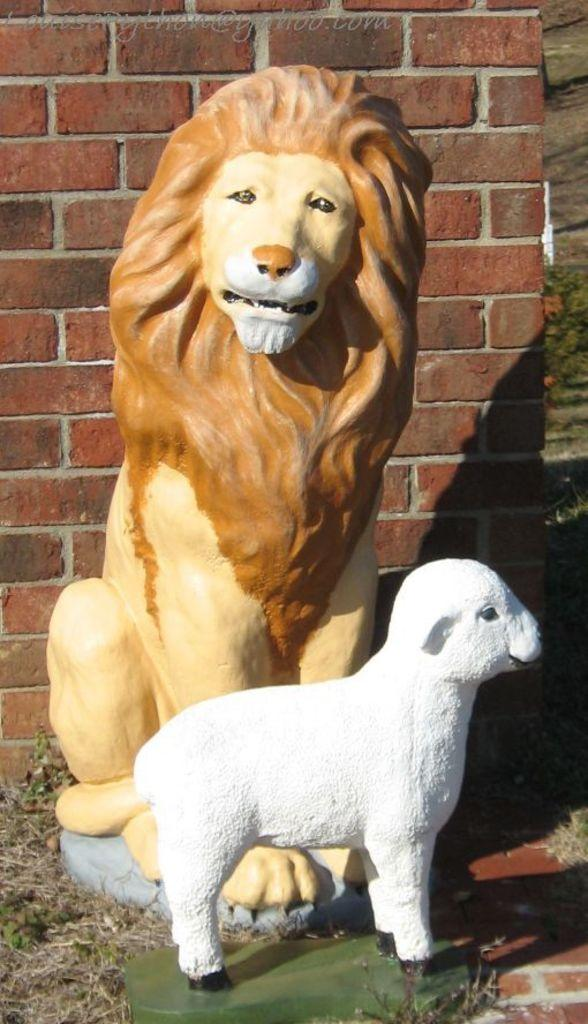What types of animal statues are in the image? There are lion and sheep statues in the image. What can be seen in the background of the image? There is a brick wall in the background of the image. What is located at the top of the image? There is text visible at the top of the image. How many clams are present in the image? There are no clams present in the image. What type of error can be seen in the text at the top of the image? There is no mention of an error in the text at the top of the image. 